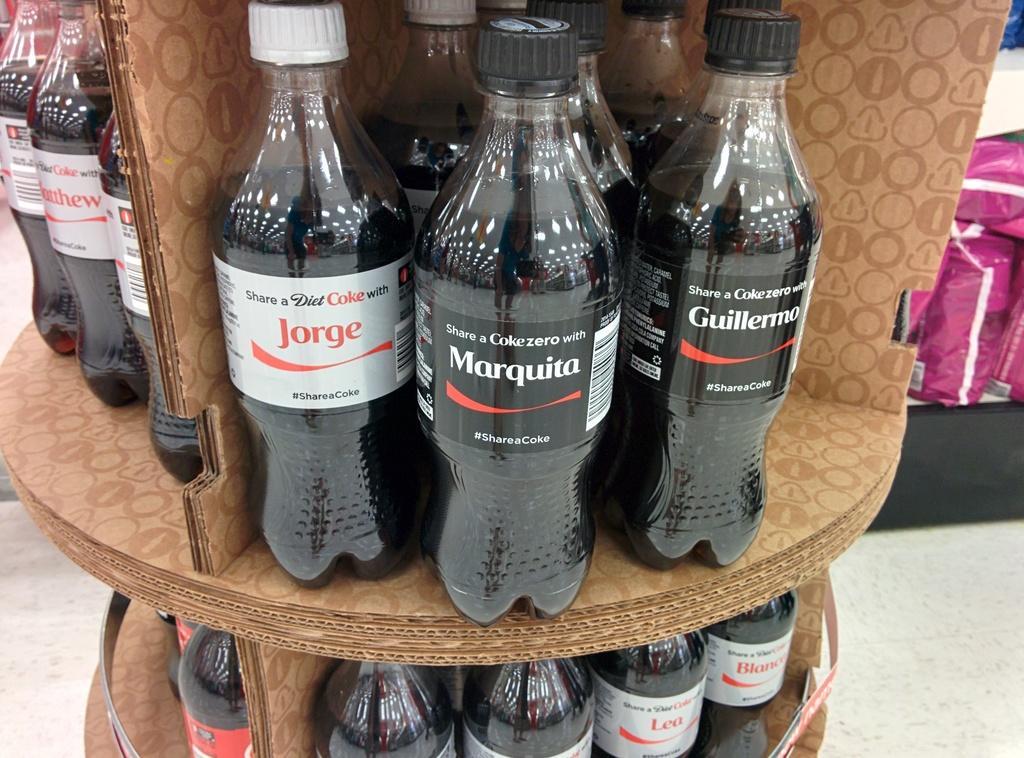Please provide a concise description of this image. In this image there are bottles with different labels on the table. At the back there are some products. 